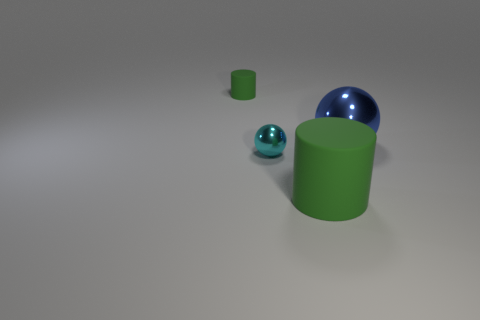There is a thing that is behind the small cyan sphere and left of the blue object; how big is it?
Your response must be concise. Small. What is the shape of the small green thing?
Keep it short and to the point. Cylinder. How many objects are brown balls or metal balls to the right of the big green cylinder?
Your answer should be very brief. 1. There is a large thing behind the small cyan shiny sphere; is it the same color as the small metal ball?
Offer a very short reply. No. What is the color of the object that is behind the cyan object and in front of the tiny cylinder?
Your answer should be compact. Blue. What material is the cylinder that is behind the cyan object?
Offer a terse response. Rubber. How big is the blue metal thing?
Your answer should be very brief. Large. What number of cyan objects are shiny things or tiny rubber cylinders?
Your answer should be very brief. 1. There is a matte object in front of the cylinder that is to the left of the big green object; how big is it?
Offer a terse response. Large. There is a tiny rubber cylinder; does it have the same color as the tiny thing that is right of the small rubber object?
Your answer should be compact. No. 